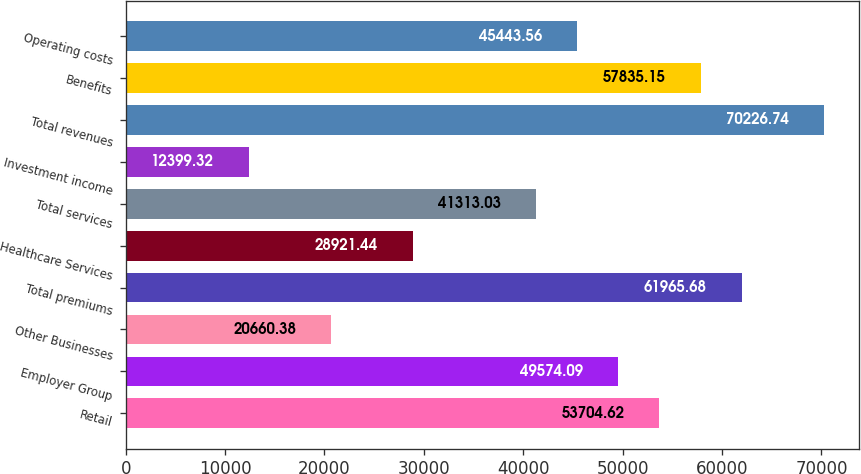Convert chart. <chart><loc_0><loc_0><loc_500><loc_500><bar_chart><fcel>Retail<fcel>Employer Group<fcel>Other Businesses<fcel>Total premiums<fcel>Healthcare Services<fcel>Total services<fcel>Investment income<fcel>Total revenues<fcel>Benefits<fcel>Operating costs<nl><fcel>53704.6<fcel>49574.1<fcel>20660.4<fcel>61965.7<fcel>28921.4<fcel>41313<fcel>12399.3<fcel>70226.7<fcel>57835.2<fcel>45443.6<nl></chart> 